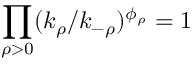<formula> <loc_0><loc_0><loc_500><loc_500>\prod _ { \rho > 0 } ( k _ { \rho } / k _ { - \rho } ) ^ { \phi _ { \rho } } = 1</formula> 